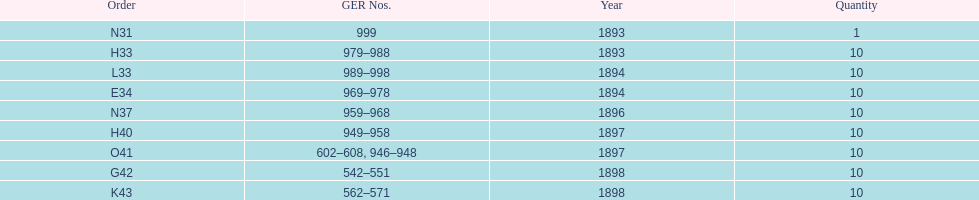Which year had the least ger numbers? 1893. 